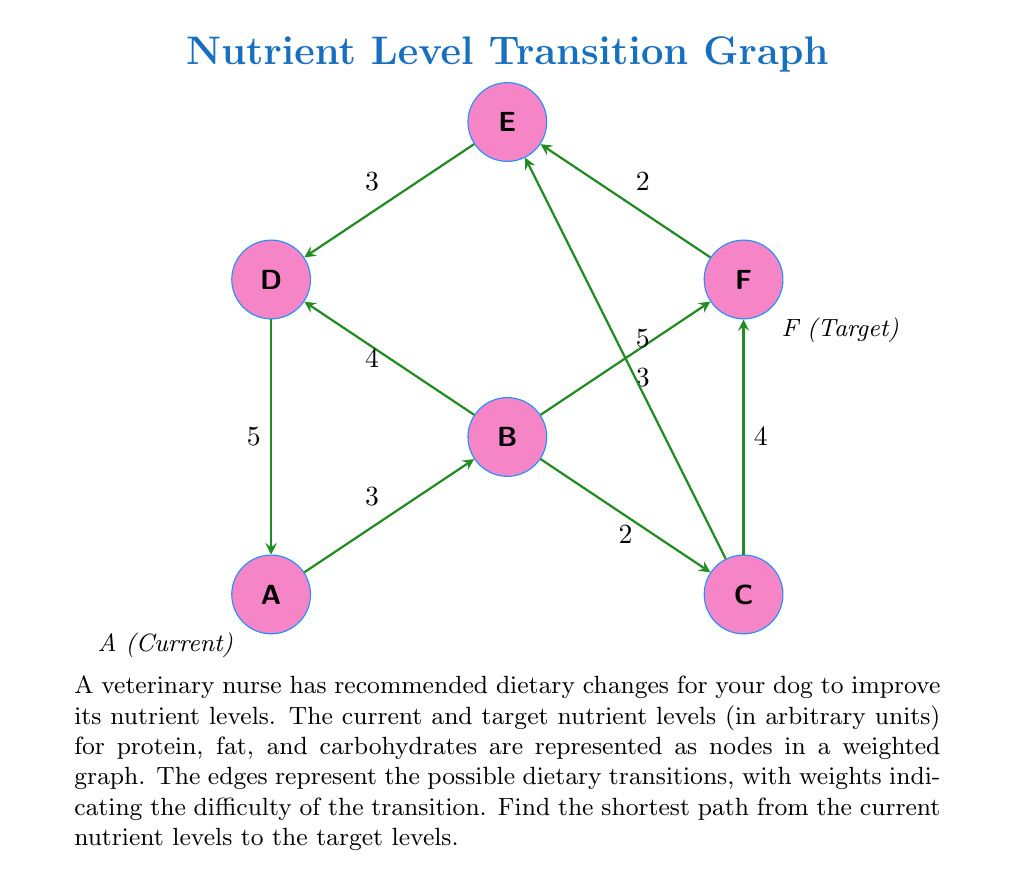Teach me how to tackle this problem. To find the shortest path between the current nutrient levels (node A) and the target levels (node F), we can use Dijkstra's algorithm. Let's go through the steps:

1) Initialize:
   - Distance to A: 0
   - Distance to all other nodes: $\infty$
   - Set of unvisited nodes: {A, B, C, D, E, F}

2) From A:
   - Update distances: B(3), D(5)
   - Mark A as visited
   - Unvisited set: {B, C, D, E, F}

3) Select B (shortest distance from A):
   - Update distances: C(5), D(min(5, 3+4)=5), F(6)
   - Mark B as visited
   - Unvisited set: {C, D, E, F}

4) Select C (shortest distance from A):
   - Update distances: F(min(6, 5+4)=6), E(10)
   - Mark C as visited
   - Unvisited set: {D, E, F}

5) Select D (shortest distance from A):
   - Update distances: E(min(10, 5+3)=8)
   - Mark D as visited
   - Unvisited set: {E, F}

6) Select F (shortest distance from A):
   - No updates needed
   - Mark F as visited
   - Unvisited set: {E}

7) The algorithm terminates as we've reached the target node F.

The shortest path from A to F is A -> B -> C -> F, with a total distance of 6.
Answer: A -> B -> C -> F, distance = 6 